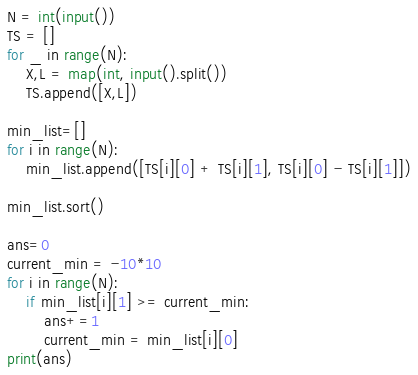<code> <loc_0><loc_0><loc_500><loc_500><_Python_>N = int(input())
TS = []
for _ in range(N):
    X,L = map(int, input().split())
    TS.append([X,L])

min_list=[]
for i in range(N):
    min_list.append([TS[i][0] + TS[i][1], TS[i][0] - TS[i][1]])

min_list.sort()

ans=0
current_min = -10*10
for i in range(N):
    if min_list[i][1] >= current_min:
        ans+=1
        current_min = min_list[i][0]
print(ans)</code> 